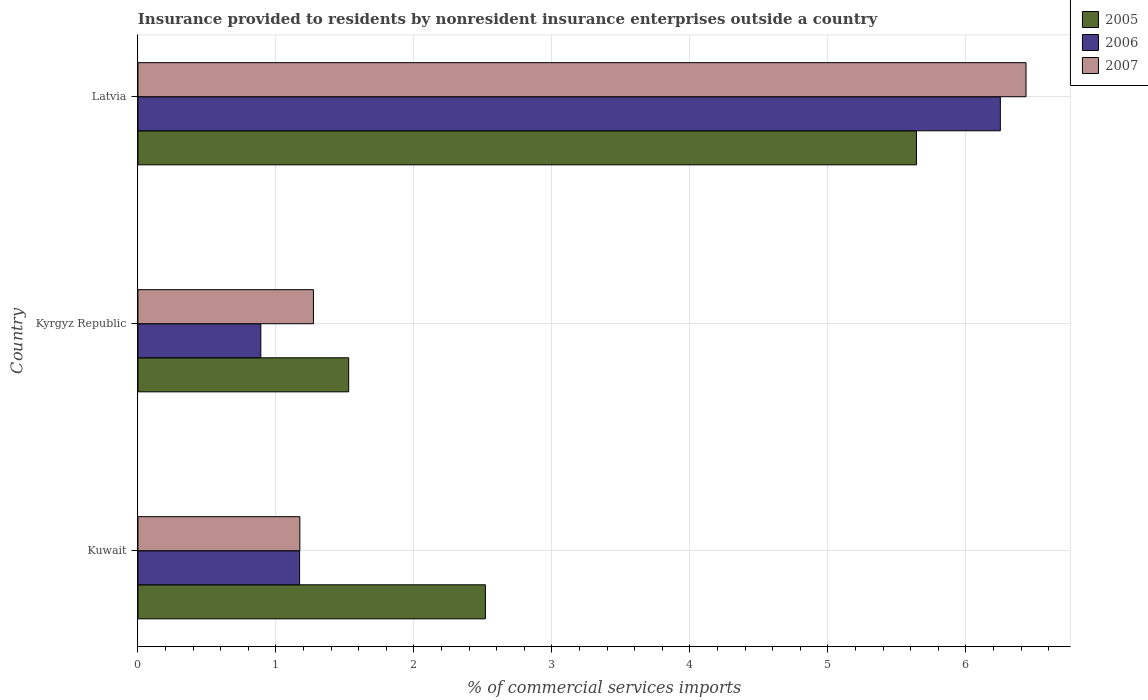How many groups of bars are there?
Provide a short and direct response. 3. Are the number of bars per tick equal to the number of legend labels?
Make the answer very short. Yes. How many bars are there on the 3rd tick from the top?
Your answer should be very brief. 3. What is the label of the 1st group of bars from the top?
Give a very brief answer. Latvia. What is the Insurance provided to residents in 2005 in Kuwait?
Offer a very short reply. 2.52. Across all countries, what is the maximum Insurance provided to residents in 2006?
Offer a very short reply. 6.25. Across all countries, what is the minimum Insurance provided to residents in 2006?
Provide a short and direct response. 0.89. In which country was the Insurance provided to residents in 2006 maximum?
Your answer should be compact. Latvia. In which country was the Insurance provided to residents in 2005 minimum?
Make the answer very short. Kyrgyz Republic. What is the total Insurance provided to residents in 2005 in the graph?
Keep it short and to the point. 9.69. What is the difference between the Insurance provided to residents in 2005 in Kuwait and that in Kyrgyz Republic?
Your response must be concise. 0.99. What is the difference between the Insurance provided to residents in 2005 in Kuwait and the Insurance provided to residents in 2006 in Latvia?
Your response must be concise. -3.73. What is the average Insurance provided to residents in 2007 per country?
Your answer should be very brief. 2.96. What is the difference between the Insurance provided to residents in 2006 and Insurance provided to residents in 2005 in Latvia?
Make the answer very short. 0.61. What is the ratio of the Insurance provided to residents in 2007 in Kuwait to that in Kyrgyz Republic?
Offer a terse response. 0.92. What is the difference between the highest and the second highest Insurance provided to residents in 2007?
Your response must be concise. 5.16. What is the difference between the highest and the lowest Insurance provided to residents in 2005?
Your answer should be compact. 4.11. What does the 3rd bar from the bottom in Kuwait represents?
Provide a short and direct response. 2007. Is it the case that in every country, the sum of the Insurance provided to residents in 2007 and Insurance provided to residents in 2005 is greater than the Insurance provided to residents in 2006?
Ensure brevity in your answer.  Yes. How many bars are there?
Provide a succinct answer. 9. Are all the bars in the graph horizontal?
Provide a short and direct response. Yes. How many countries are there in the graph?
Provide a succinct answer. 3. What is the difference between two consecutive major ticks on the X-axis?
Your response must be concise. 1. Does the graph contain any zero values?
Give a very brief answer. No. Does the graph contain grids?
Give a very brief answer. Yes. How are the legend labels stacked?
Offer a very short reply. Vertical. What is the title of the graph?
Provide a short and direct response. Insurance provided to residents by nonresident insurance enterprises outside a country. What is the label or title of the X-axis?
Offer a very short reply. % of commercial services imports. What is the % of commercial services imports in 2005 in Kuwait?
Your answer should be very brief. 2.52. What is the % of commercial services imports in 2006 in Kuwait?
Make the answer very short. 1.17. What is the % of commercial services imports in 2007 in Kuwait?
Give a very brief answer. 1.17. What is the % of commercial services imports in 2005 in Kyrgyz Republic?
Offer a terse response. 1.53. What is the % of commercial services imports in 2006 in Kyrgyz Republic?
Provide a succinct answer. 0.89. What is the % of commercial services imports in 2007 in Kyrgyz Republic?
Provide a short and direct response. 1.27. What is the % of commercial services imports of 2005 in Latvia?
Ensure brevity in your answer.  5.64. What is the % of commercial services imports in 2006 in Latvia?
Ensure brevity in your answer.  6.25. What is the % of commercial services imports of 2007 in Latvia?
Your answer should be very brief. 6.44. Across all countries, what is the maximum % of commercial services imports in 2005?
Provide a succinct answer. 5.64. Across all countries, what is the maximum % of commercial services imports of 2006?
Offer a terse response. 6.25. Across all countries, what is the maximum % of commercial services imports in 2007?
Make the answer very short. 6.44. Across all countries, what is the minimum % of commercial services imports in 2005?
Keep it short and to the point. 1.53. Across all countries, what is the minimum % of commercial services imports of 2006?
Provide a succinct answer. 0.89. Across all countries, what is the minimum % of commercial services imports of 2007?
Give a very brief answer. 1.17. What is the total % of commercial services imports of 2005 in the graph?
Provide a succinct answer. 9.69. What is the total % of commercial services imports of 2006 in the graph?
Offer a terse response. 8.31. What is the total % of commercial services imports of 2007 in the graph?
Make the answer very short. 8.88. What is the difference between the % of commercial services imports of 2005 in Kuwait and that in Kyrgyz Republic?
Provide a succinct answer. 0.99. What is the difference between the % of commercial services imports in 2006 in Kuwait and that in Kyrgyz Republic?
Your answer should be very brief. 0.28. What is the difference between the % of commercial services imports of 2007 in Kuwait and that in Kyrgyz Republic?
Provide a succinct answer. -0.1. What is the difference between the % of commercial services imports of 2005 in Kuwait and that in Latvia?
Your answer should be compact. -3.12. What is the difference between the % of commercial services imports of 2006 in Kuwait and that in Latvia?
Provide a short and direct response. -5.08. What is the difference between the % of commercial services imports of 2007 in Kuwait and that in Latvia?
Make the answer very short. -5.26. What is the difference between the % of commercial services imports of 2005 in Kyrgyz Republic and that in Latvia?
Offer a very short reply. -4.11. What is the difference between the % of commercial services imports in 2006 in Kyrgyz Republic and that in Latvia?
Ensure brevity in your answer.  -5.36. What is the difference between the % of commercial services imports of 2007 in Kyrgyz Republic and that in Latvia?
Your answer should be very brief. -5.16. What is the difference between the % of commercial services imports of 2005 in Kuwait and the % of commercial services imports of 2006 in Kyrgyz Republic?
Ensure brevity in your answer.  1.63. What is the difference between the % of commercial services imports of 2005 in Kuwait and the % of commercial services imports of 2007 in Kyrgyz Republic?
Make the answer very short. 1.25. What is the difference between the % of commercial services imports in 2006 in Kuwait and the % of commercial services imports in 2007 in Kyrgyz Republic?
Give a very brief answer. -0.1. What is the difference between the % of commercial services imports in 2005 in Kuwait and the % of commercial services imports in 2006 in Latvia?
Give a very brief answer. -3.73. What is the difference between the % of commercial services imports in 2005 in Kuwait and the % of commercial services imports in 2007 in Latvia?
Provide a succinct answer. -3.92. What is the difference between the % of commercial services imports in 2006 in Kuwait and the % of commercial services imports in 2007 in Latvia?
Your response must be concise. -5.26. What is the difference between the % of commercial services imports of 2005 in Kyrgyz Republic and the % of commercial services imports of 2006 in Latvia?
Offer a very short reply. -4.72. What is the difference between the % of commercial services imports in 2005 in Kyrgyz Republic and the % of commercial services imports in 2007 in Latvia?
Make the answer very short. -4.91. What is the difference between the % of commercial services imports of 2006 in Kyrgyz Republic and the % of commercial services imports of 2007 in Latvia?
Offer a very short reply. -5.54. What is the average % of commercial services imports of 2005 per country?
Keep it short and to the point. 3.23. What is the average % of commercial services imports of 2006 per country?
Your answer should be very brief. 2.77. What is the average % of commercial services imports in 2007 per country?
Offer a terse response. 2.96. What is the difference between the % of commercial services imports of 2005 and % of commercial services imports of 2006 in Kuwait?
Make the answer very short. 1.35. What is the difference between the % of commercial services imports of 2005 and % of commercial services imports of 2007 in Kuwait?
Your response must be concise. 1.34. What is the difference between the % of commercial services imports of 2006 and % of commercial services imports of 2007 in Kuwait?
Provide a short and direct response. -0. What is the difference between the % of commercial services imports of 2005 and % of commercial services imports of 2006 in Kyrgyz Republic?
Your answer should be compact. 0.64. What is the difference between the % of commercial services imports in 2005 and % of commercial services imports in 2007 in Kyrgyz Republic?
Your response must be concise. 0.26. What is the difference between the % of commercial services imports of 2006 and % of commercial services imports of 2007 in Kyrgyz Republic?
Your answer should be compact. -0.38. What is the difference between the % of commercial services imports in 2005 and % of commercial services imports in 2006 in Latvia?
Provide a succinct answer. -0.61. What is the difference between the % of commercial services imports of 2005 and % of commercial services imports of 2007 in Latvia?
Keep it short and to the point. -0.79. What is the difference between the % of commercial services imports of 2006 and % of commercial services imports of 2007 in Latvia?
Offer a very short reply. -0.19. What is the ratio of the % of commercial services imports in 2005 in Kuwait to that in Kyrgyz Republic?
Provide a short and direct response. 1.65. What is the ratio of the % of commercial services imports of 2006 in Kuwait to that in Kyrgyz Republic?
Provide a short and direct response. 1.32. What is the ratio of the % of commercial services imports of 2007 in Kuwait to that in Kyrgyz Republic?
Give a very brief answer. 0.92. What is the ratio of the % of commercial services imports in 2005 in Kuwait to that in Latvia?
Offer a very short reply. 0.45. What is the ratio of the % of commercial services imports of 2006 in Kuwait to that in Latvia?
Your response must be concise. 0.19. What is the ratio of the % of commercial services imports in 2007 in Kuwait to that in Latvia?
Provide a succinct answer. 0.18. What is the ratio of the % of commercial services imports in 2005 in Kyrgyz Republic to that in Latvia?
Offer a terse response. 0.27. What is the ratio of the % of commercial services imports in 2006 in Kyrgyz Republic to that in Latvia?
Offer a terse response. 0.14. What is the ratio of the % of commercial services imports in 2007 in Kyrgyz Republic to that in Latvia?
Offer a terse response. 0.2. What is the difference between the highest and the second highest % of commercial services imports in 2005?
Your answer should be compact. 3.12. What is the difference between the highest and the second highest % of commercial services imports in 2006?
Provide a short and direct response. 5.08. What is the difference between the highest and the second highest % of commercial services imports of 2007?
Provide a succinct answer. 5.16. What is the difference between the highest and the lowest % of commercial services imports of 2005?
Your response must be concise. 4.11. What is the difference between the highest and the lowest % of commercial services imports in 2006?
Your answer should be very brief. 5.36. What is the difference between the highest and the lowest % of commercial services imports in 2007?
Your response must be concise. 5.26. 